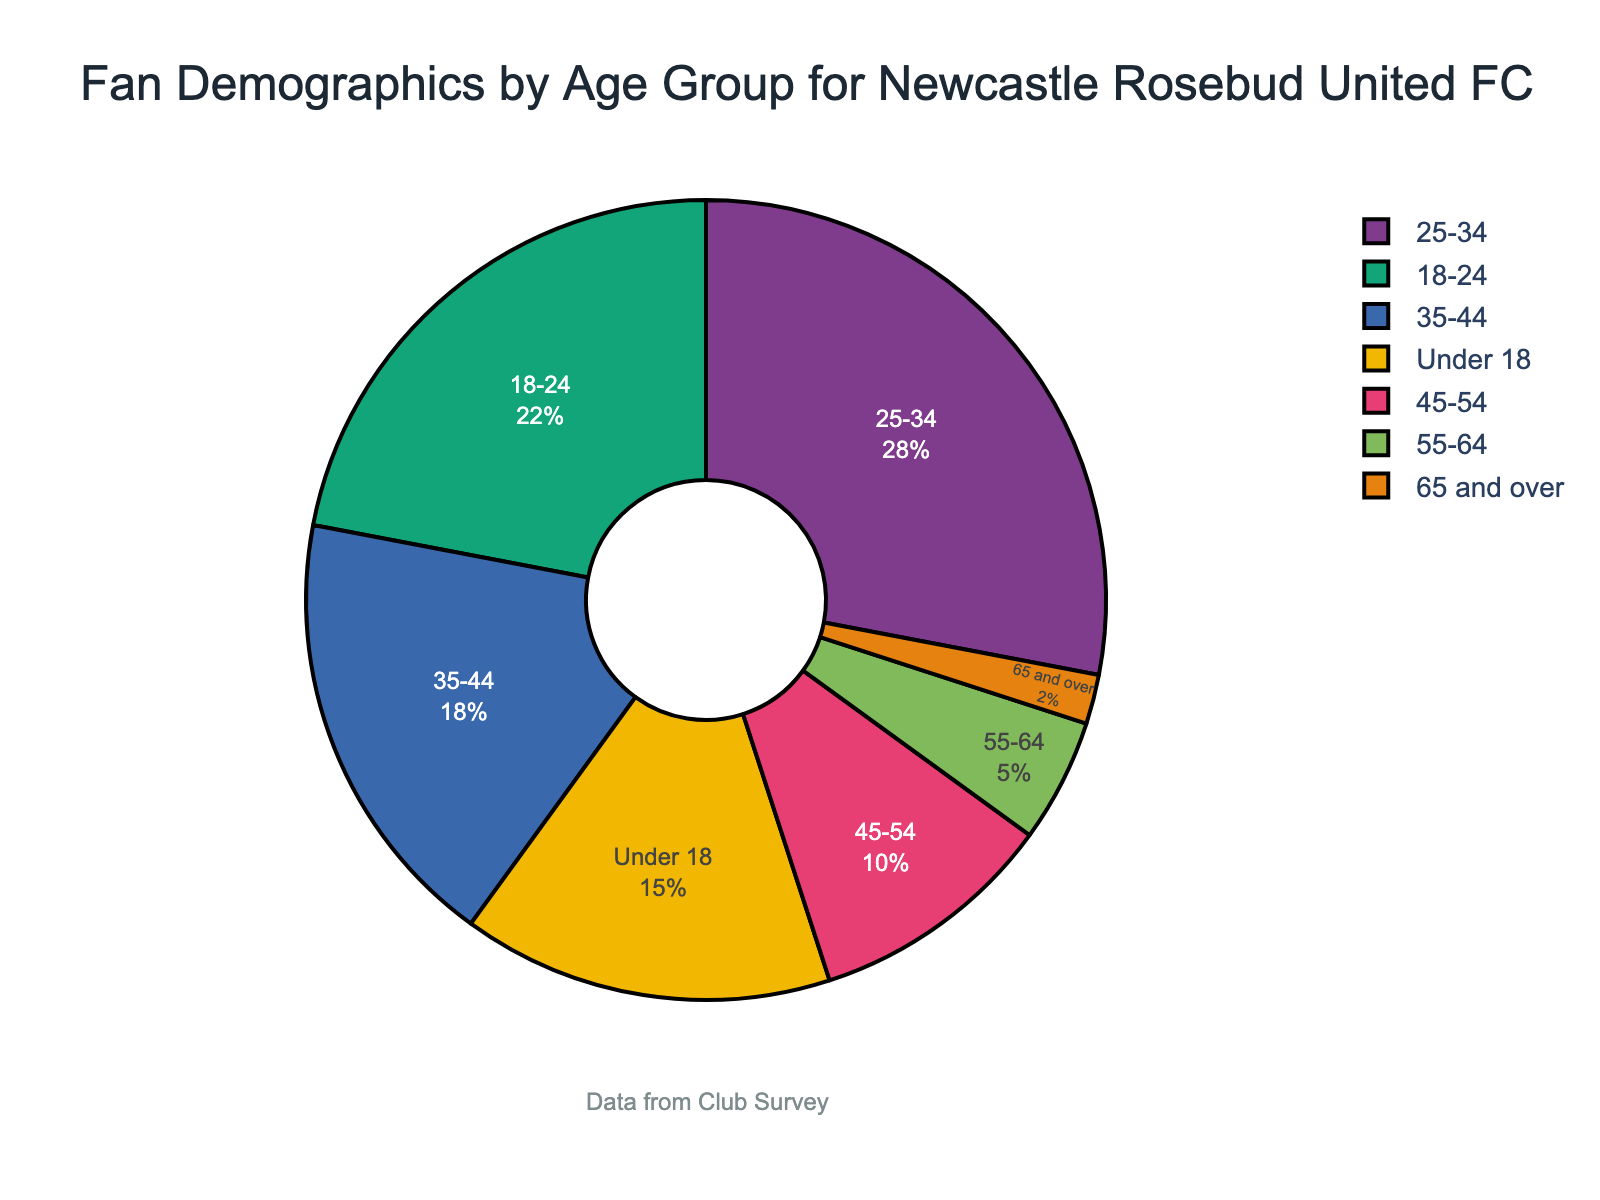Which age group has the highest percentage of fans? The pie chart shows the distribution of fan demographics by age group. The largest segment in the chart represents the 25-34 age group with 28%.
Answer: 25-34 Which age group has the smallest percentage of fans? In the pie chart, the section for the 65 and over age group is the smallest, indicating it has the lowest percentage at 2%.
Answer: 65 and over What is the total percentage of fans who are either under 18 or over 65? Add the percentage of fans under 18 (15%) with those over 65 (2%). 15% + 2% = 17%.
Answer: 17% How do the percentages of fans aged 18-24 and 45-54 compare? The percentage for the 18-24 age group is 22%, and for the 45-54 age group, it is 10%. 22% is greater than 10%.
Answer: 18-24 is greater Which age group represents a higher percentage of fans, 35-44 or 55-64? The percentage for the 35-44 age group is 18%, whereas for the 55-64 age group, it is 5%. 18% is higher than 5%.
Answer: 35-44 is higher What is the combined percentage of fans aged between 35 and 54? Add the percentages for the 35-44 age group (18%) and the 45-54 age group (10%). 18% + 10% = 28%.
Answer: 28% What is the percentage difference between fans aged under 18 and 65 and over? Subtract the percentage of fans aged 65 and over (2%) from those under 18 (15%). 15% - 2% = 13%.
Answer: 13% Which age group covers a quarter of the pie chart? Check the percentage values in the chart. The only age group with approximately a quarter (25%) is the 25-34 age group with 28%.
Answer: 25-34 Does the 18-24 age group have a percentage closer to that of the 25-34 or the 35-44 age group? 18-24 age group has 22%, 25-34 has 28%, and 35-44 has 18%. The difference from 18-24 to 25-34 is 6%, and the difference to 35-44 is 4%. It is closer to the 35-44 group.
Answer: 35-44 